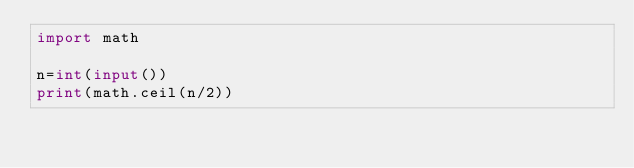<code> <loc_0><loc_0><loc_500><loc_500><_Python_>import math

n=int(input())
print(math.ceil(n/2))</code> 